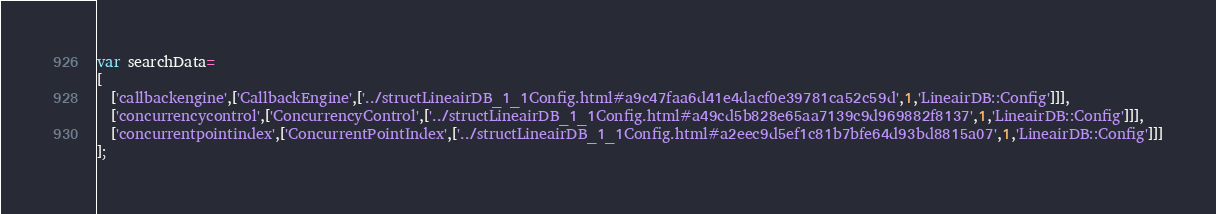Convert code to text. <code><loc_0><loc_0><loc_500><loc_500><_JavaScript_>var searchData=
[
  ['callbackengine',['CallbackEngine',['../structLineairDB_1_1Config.html#a9c47faa6d41e4dacf0e39781ca52c59d',1,'LineairDB::Config']]],
  ['concurrencycontrol',['ConcurrencyControl',['../structLineairDB_1_1Config.html#a49cd5b828e65aa7139c9d969882f8137',1,'LineairDB::Config']]],
  ['concurrentpointindex',['ConcurrentPointIndex',['../structLineairDB_1_1Config.html#a2eec9d5ef1c81b7bfe64d93bd8815a07',1,'LineairDB::Config']]]
];
</code> 